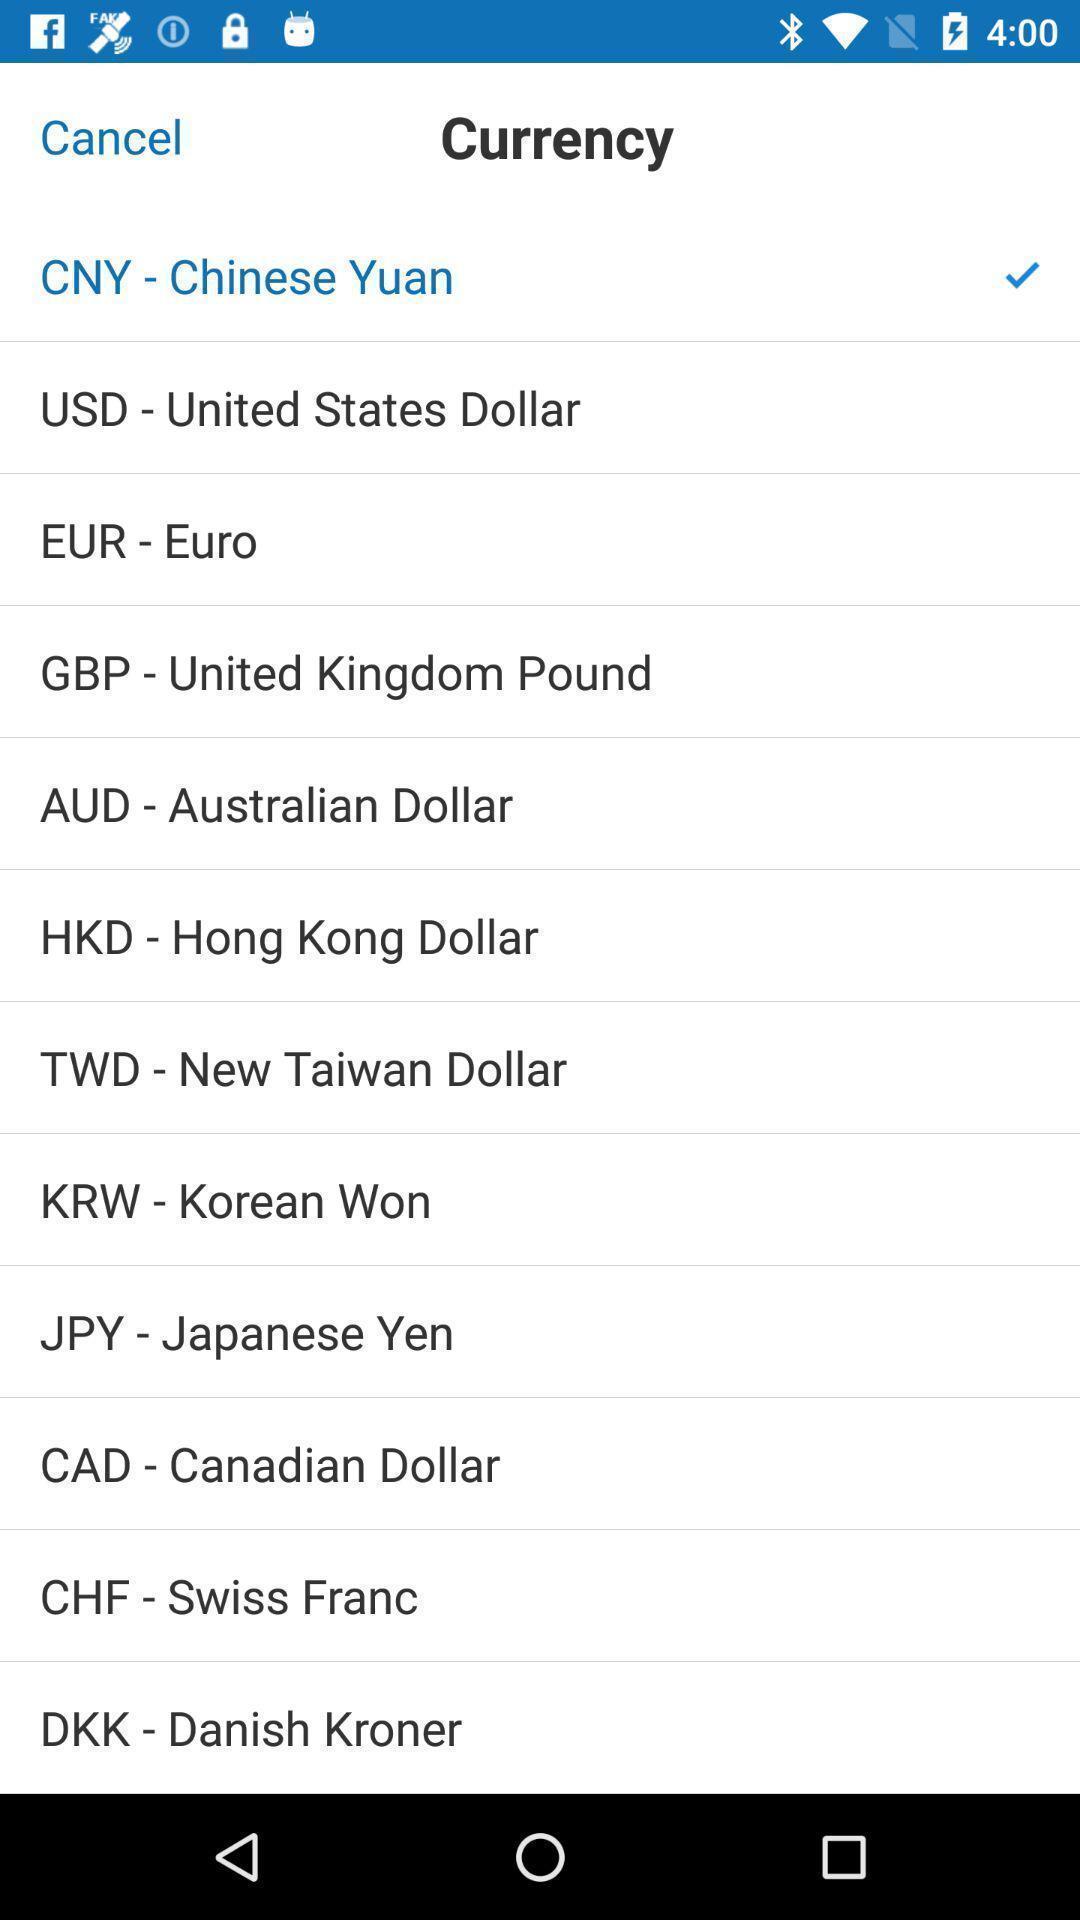Describe this image in words. Page showing different currency names. 